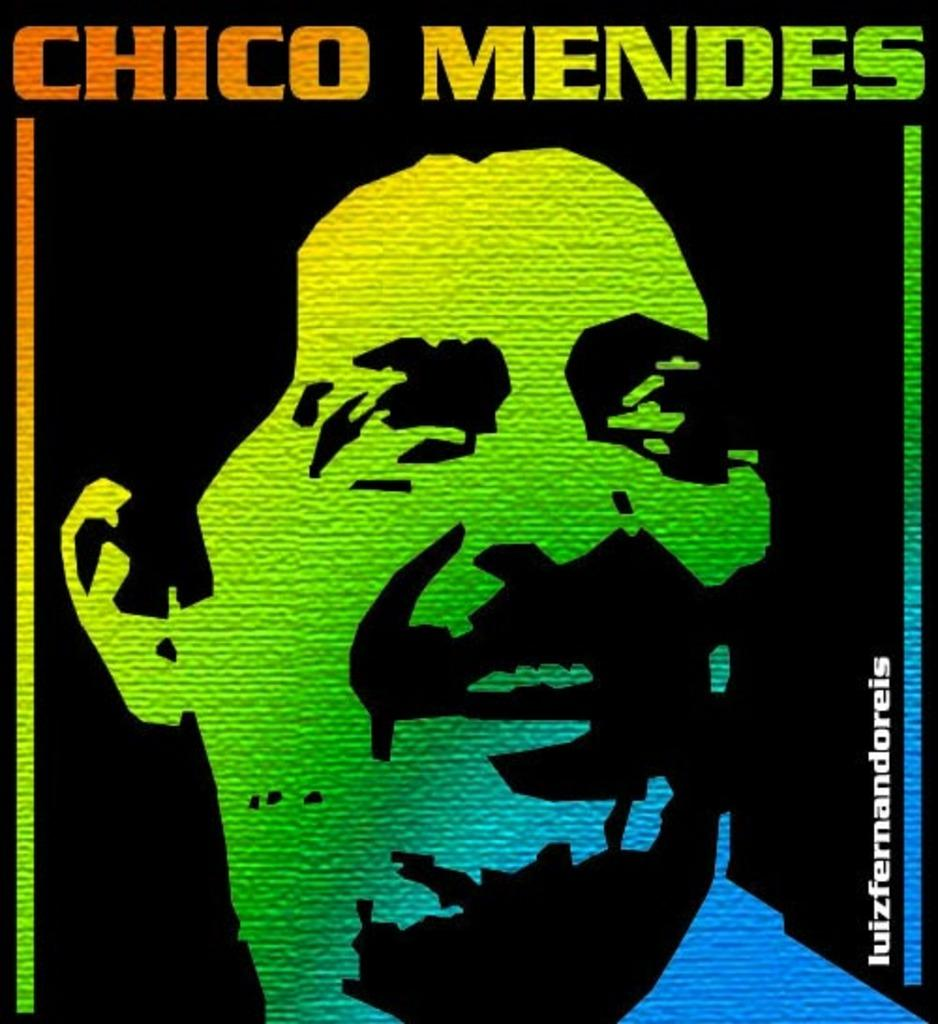<image>
Share a concise interpretation of the image provided. A rainbow silhouette of a man names Chico Mendes. 